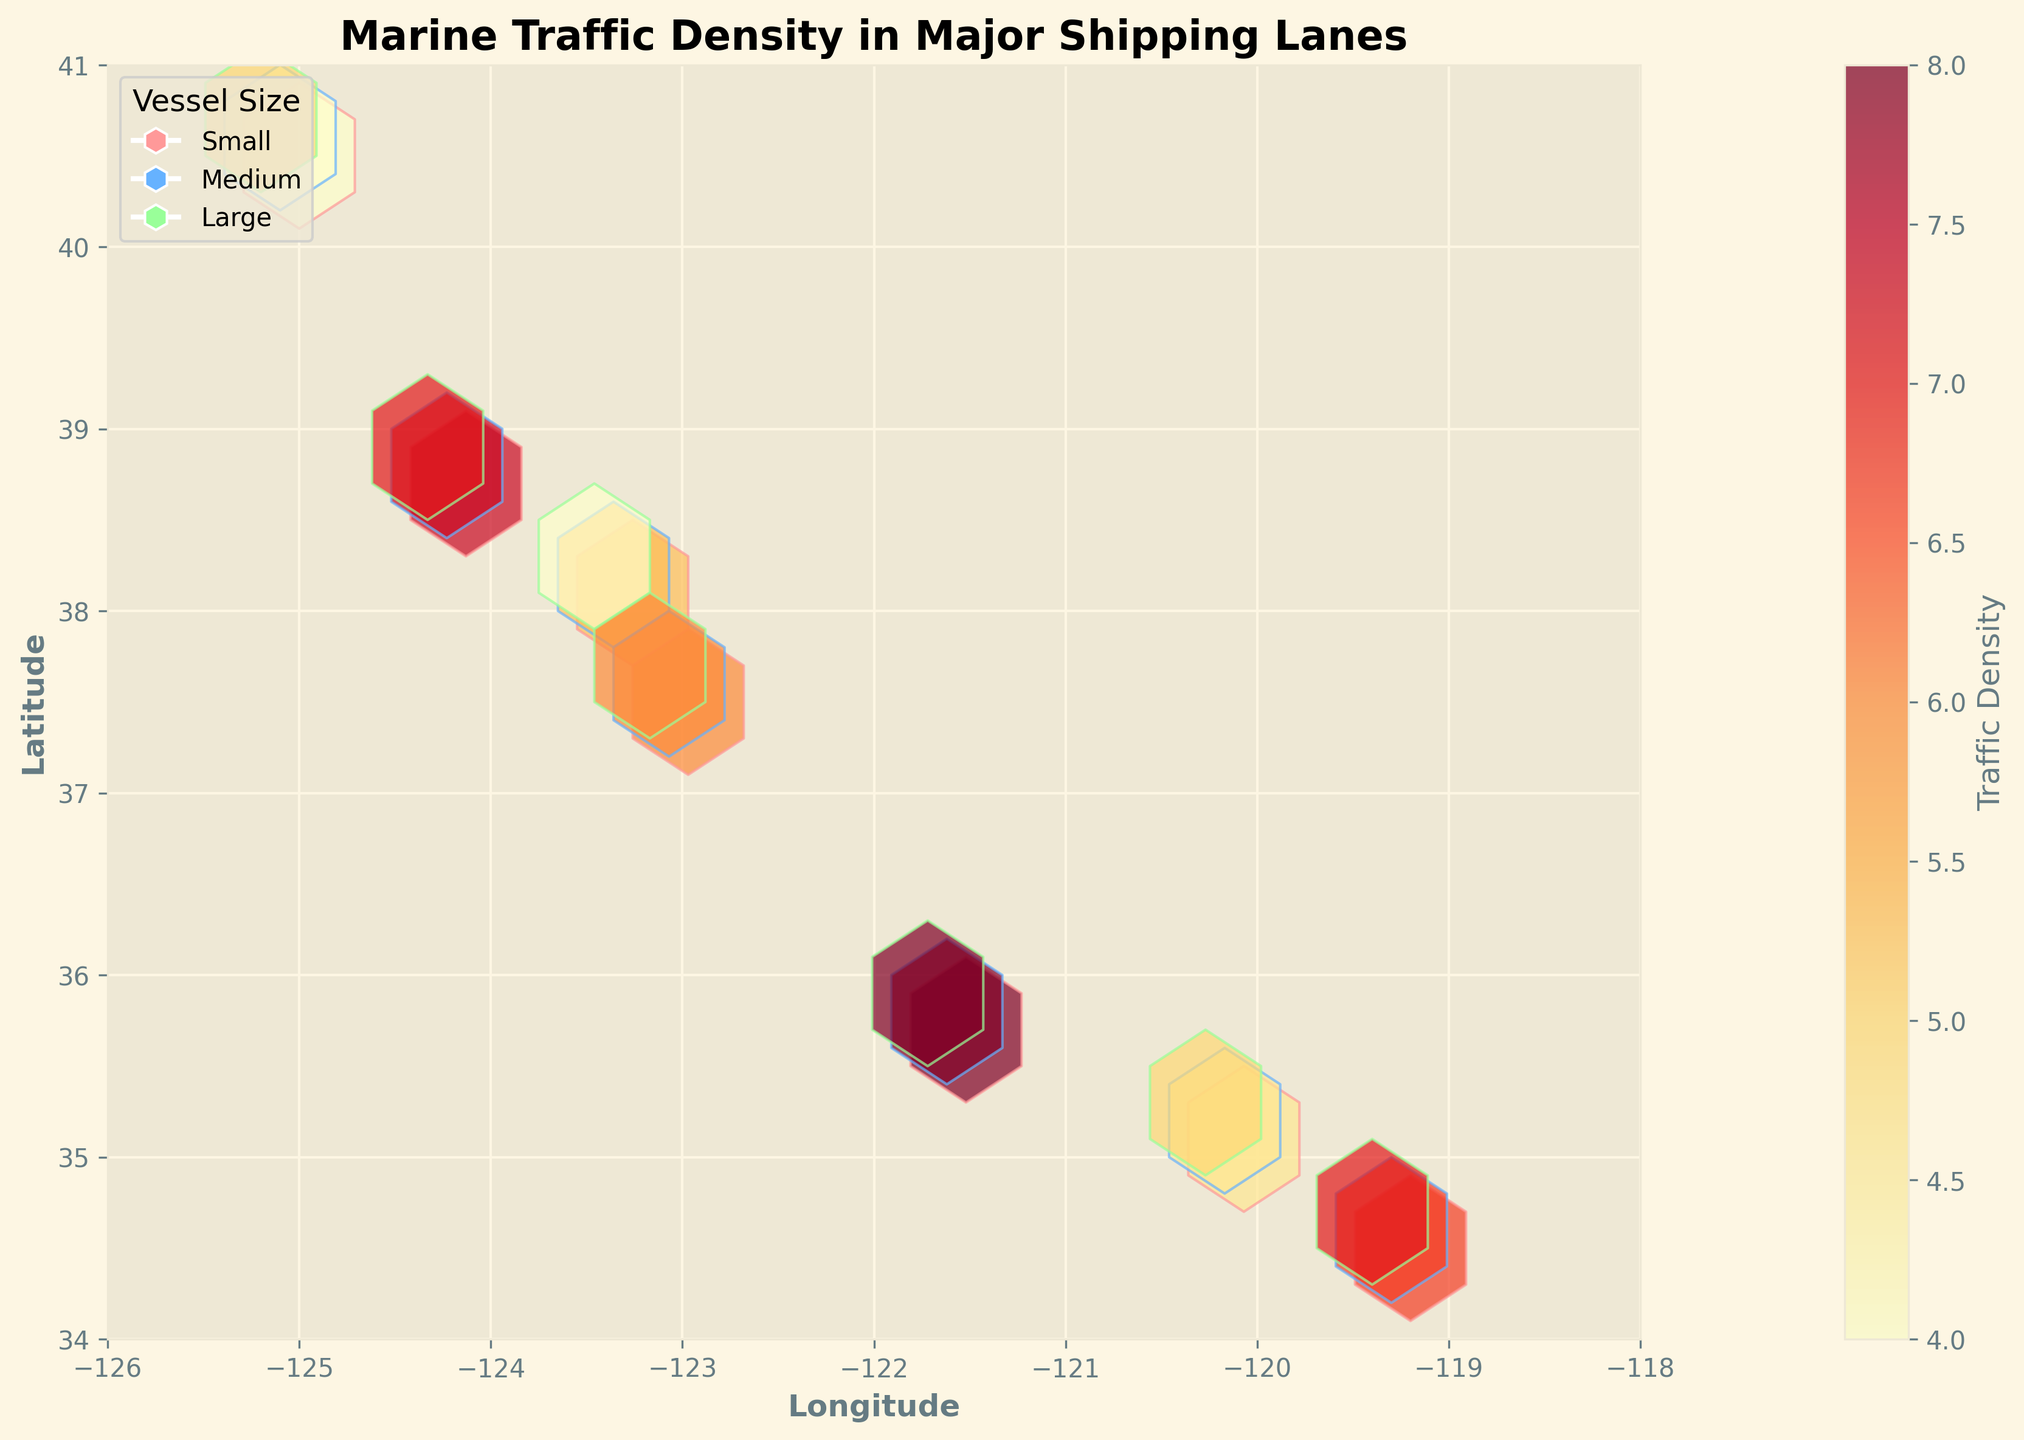What is the title of the plot? The title is typically located at the top center of the plot. In this case, it reads "Marine Traffic Density in Major Shipping Lanes."
Answer: Marine Traffic Density in Major Shipping Lanes What are the labels of the x-axis and y-axis? The labels of the axes are generally indicated along the respective axes. For this figure, the x-axis is labeled "Longitude," and the y-axis is labeled "Latitude."
Answer: Longitude, Latitude Which vessel size appears to have the highest density of marine traffic in the plot? By examining the color intensity (with the help of the color bar) and the frequency of hexagons, one can determine which vessel size has the highest traffic density. Here, the medium size vessels (blue color) have the highest density.
Answer: Medium What color represents small vessels in the plot? In the plot legend, small vessels are represented by a pinkish color. The legend matches each vessel size type to a specific color.
Answer: Pinkish Which vessel size has the lowest density in the plot? By considering the color intensity, the vessel size with the least saturated color often implies lower density. Here, the large size vessels (green color) exhibit the lowest density.
Answer: Large Between the longitudes of -126 to -118 and latitudes of 34 to 41, where is the highest traffic density found? By analyzing the hexbin plot and color intensity, the areas with the darkest red hexagons represent the highest traffic density. It appears near the coordinates (36.1, -121.6).
Answer: Near (36.1, -121.6) How is the traffic density color-coded in this plot? According to the color bar, the traffic density is color-coded from light yellow to dark red, where lighter shades represent lower density, and darker shades indicate higher density.
Answer: From light yellow to dark red What does the shading pattern within each hexbin indicate? The shading within each hexbin corresponds to the traffic density of marine vessels. Darker shades signify higher vessel density, whereas lighter shades suggest lower density.
Answer: Higher density for darker shades, lower density for lighter shades How does the traffic density compare between small vessels and large vessels at the latitude of approximately 37.7? By observing the hexbins near the latitude of 37.7, the small vessels (pinkish) exhibit a higher traffic density than the large vessels (green) for the similar longitude range.
Answer: Higher density for small vessels Is there a significant traffic density difference observed across different negative longitudes (from -126 to -118)? The hexbin plot shows variability in density across different longitudes. General observation indicates higher densities nearer to longitudes -121.6 and lower densities at the edges (-126 and -118).
Answer: Yes, higher near -121.6, lower at edges 